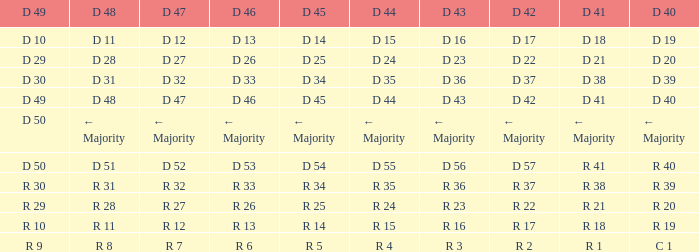I seek the d 46 for d 45 of r 5 R 6. 